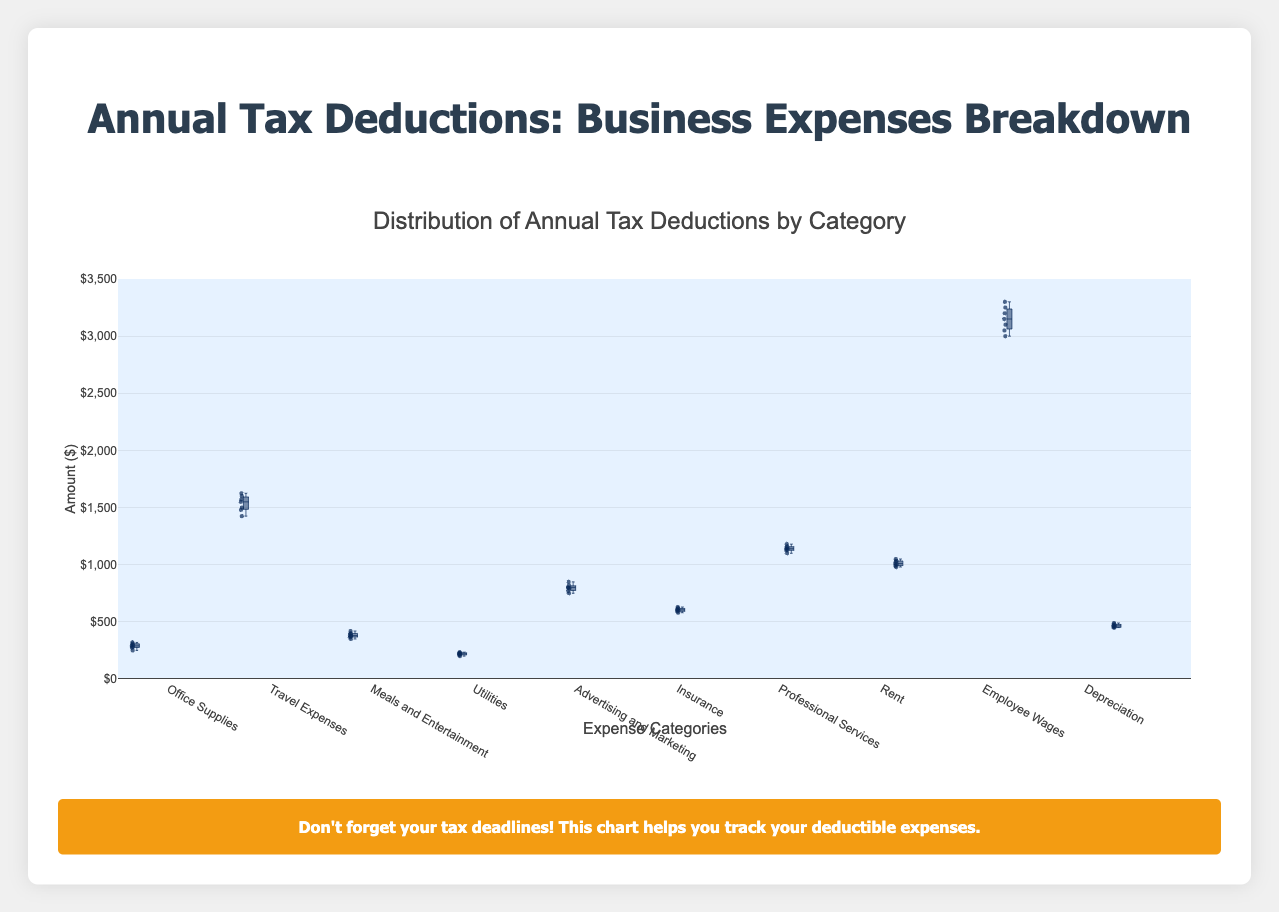What is the title of the chart? The title is displayed at the top of the chart and reads 'Distribution of Annual Tax Deductions by Category'.
Answer: Distribution of Annual Tax Deductions by Category What is the range of the y-axis? The y-axis range is determined by the chart, and it goes from 0 to 3500, as specified in the plot settings.
Answer: 0 to 3500 Which category has the highest median value? To find this, look for the category whose box is highest on the y-axis. The 'Employee Wages' category has its median line at the highest position.
Answer: Employee Wages How many categories are represented in the chart? Count the number of boxes, as each represents one category. There are 10 categories in total.
Answer: 10 Which category shows the most variability in values? The width of the interquartile range (IQR) and the lengths of the whiskers indicate variability. The 'Employee Wages' category, with wider IQR and longer whiskers, shows the most variability.
Answer: Employee Wages Which categories have a median value that is closest to $1000? Look for the boxes whose median line is near the $1000 mark on the y-axis. The 'Rent' category has its median close to $1000.
Answer: Rent What is the median value of 'Depreciation'? The median of 'Depreciation' can be found where the line inside the box is positioned. It's approximately $465.
Answer: $465 Which category has the lowest maximum value? The maximum value is found at the top end of the whiskers. 'Utilities' has the lowest maximum value among all categories.
Answer: Utilities Does the 'Advertising and Marketing' category have any outliers? Outliers are individual points outside the whiskers. For 'Advertising and Marketing,' there are no points outside the whiskers indicating no outliers.
Answer: No Compare the median values of 'Office Supplies' and 'Insurance'. Which one is higher? Compare the median lines of the two categories. 'Insurance' has a median line higher than 'Office Supplies'.
Answer: Insurance 